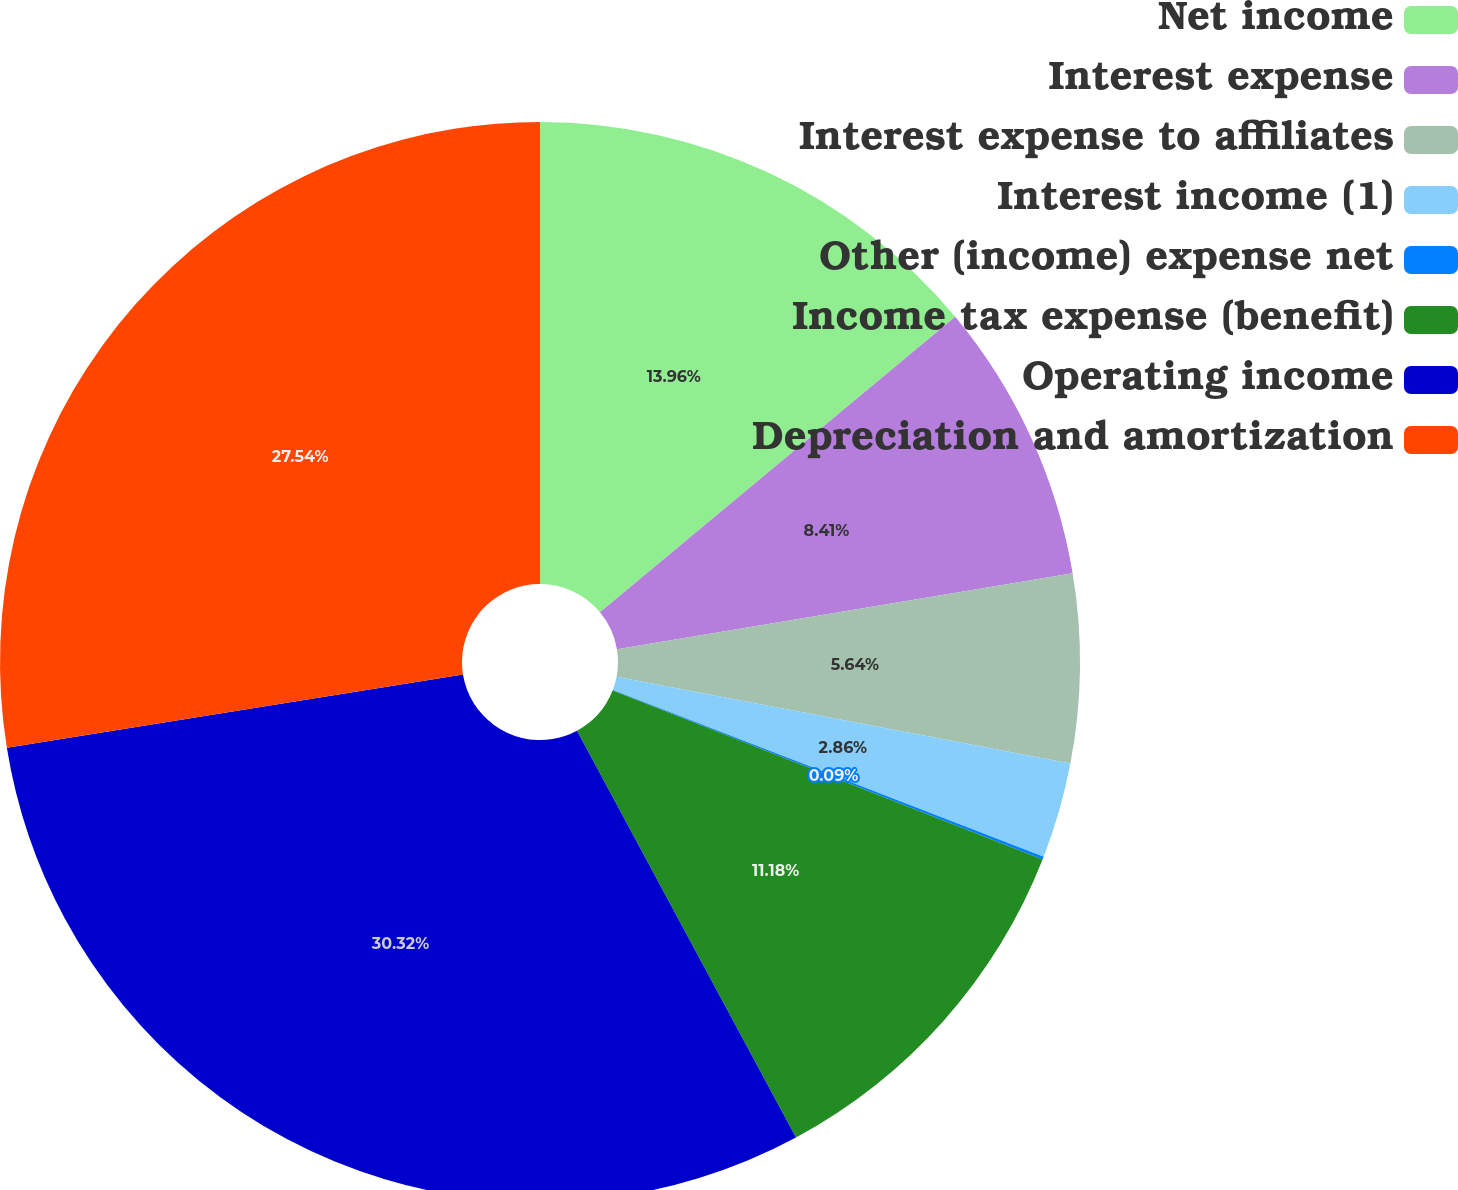Convert chart to OTSL. <chart><loc_0><loc_0><loc_500><loc_500><pie_chart><fcel>Net income<fcel>Interest expense<fcel>Interest expense to affiliates<fcel>Interest income (1)<fcel>Other (income) expense net<fcel>Income tax expense (benefit)<fcel>Operating income<fcel>Depreciation and amortization<nl><fcel>13.96%<fcel>8.41%<fcel>5.64%<fcel>2.86%<fcel>0.09%<fcel>11.18%<fcel>30.32%<fcel>27.54%<nl></chart> 